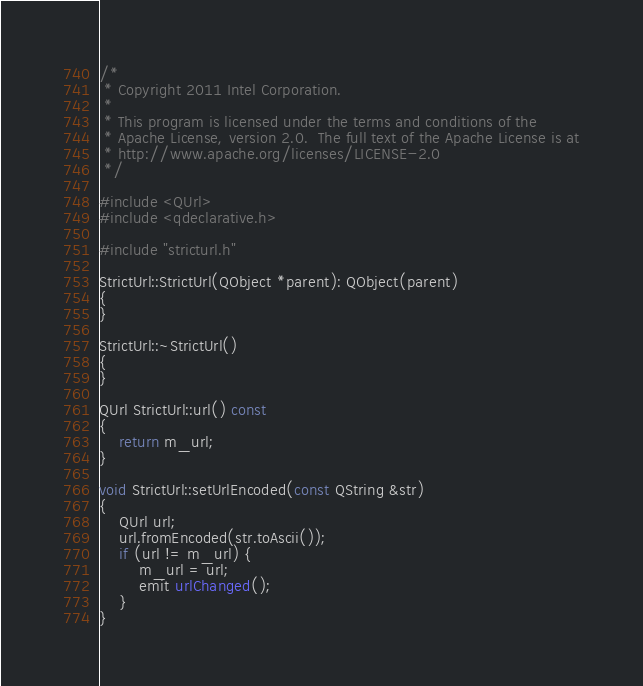Convert code to text. <code><loc_0><loc_0><loc_500><loc_500><_C++_>/*
 * Copyright 2011 Intel Corporation.
 *
 * This program is licensed under the terms and conditions of the
 * Apache License, version 2.0.  The full text of the Apache License is at
 * http://www.apache.org/licenses/LICENSE-2.0
 */

#include <QUrl>
#include <qdeclarative.h>

#include "stricturl.h"

StrictUrl::StrictUrl(QObject *parent): QObject(parent)
{
}

StrictUrl::~StrictUrl()
{
}

QUrl StrictUrl::url() const
{
    return m_url;
}

void StrictUrl::setUrlEncoded(const QString &str)
{
    QUrl url;
    url.fromEncoded(str.toAscii());
    if (url != m_url) {
        m_url = url;
        emit urlChanged();
    }
}
</code> 